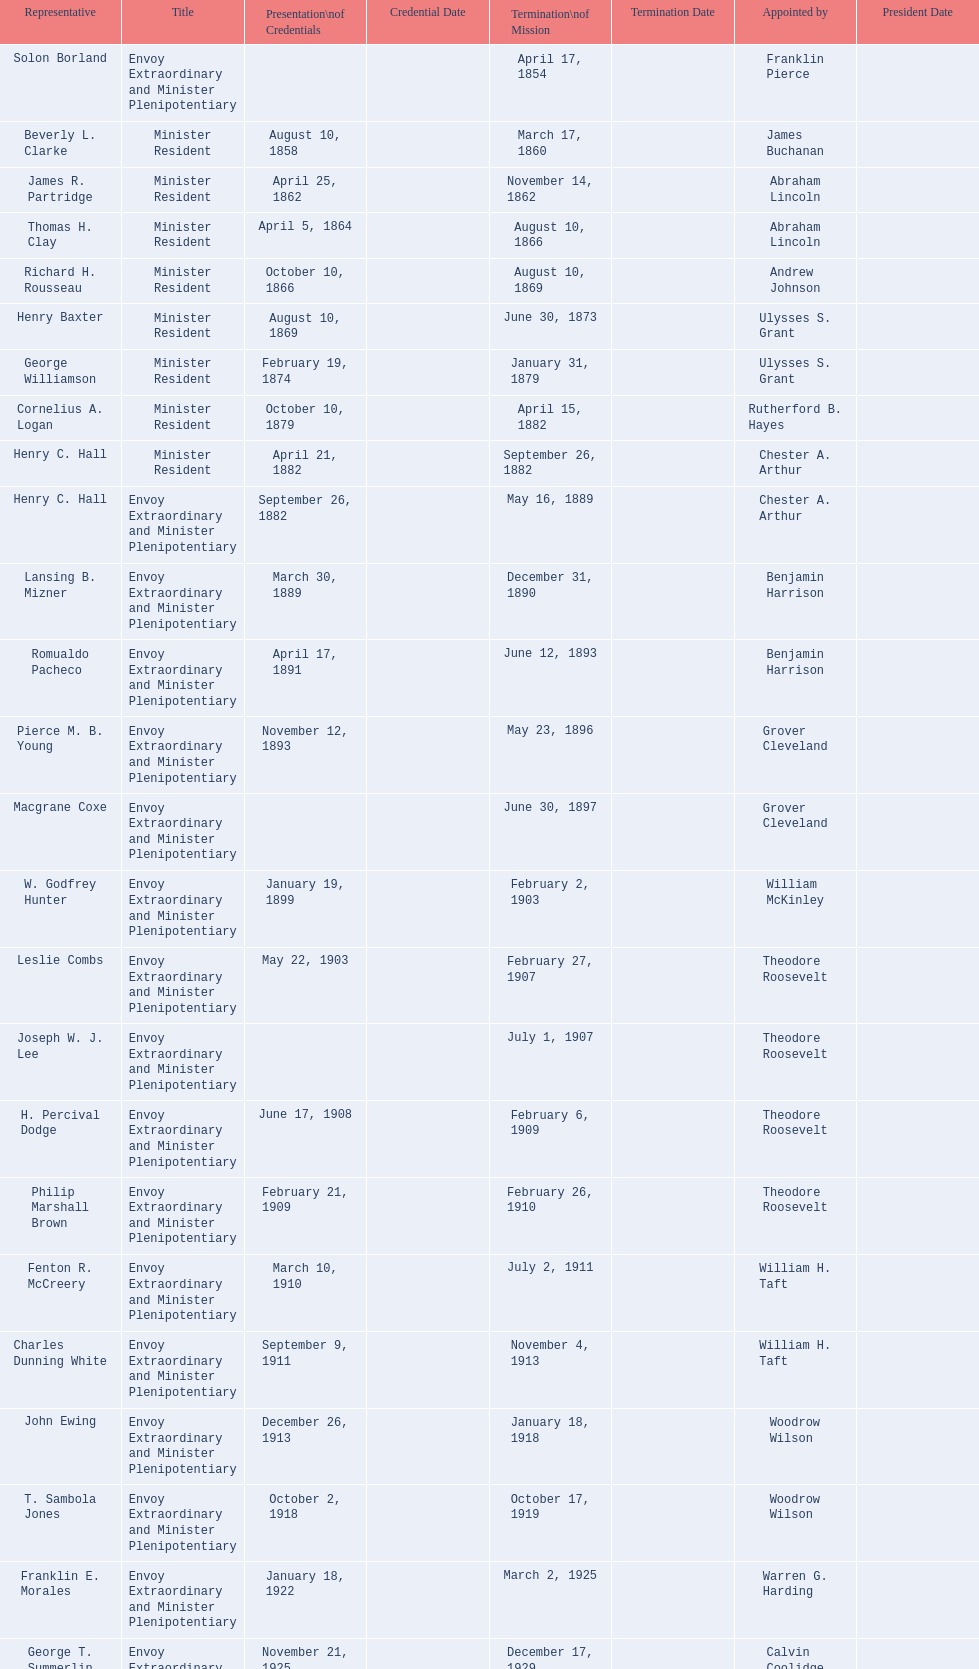Who had the shortest term as a minister resident? Henry C. Hall. 